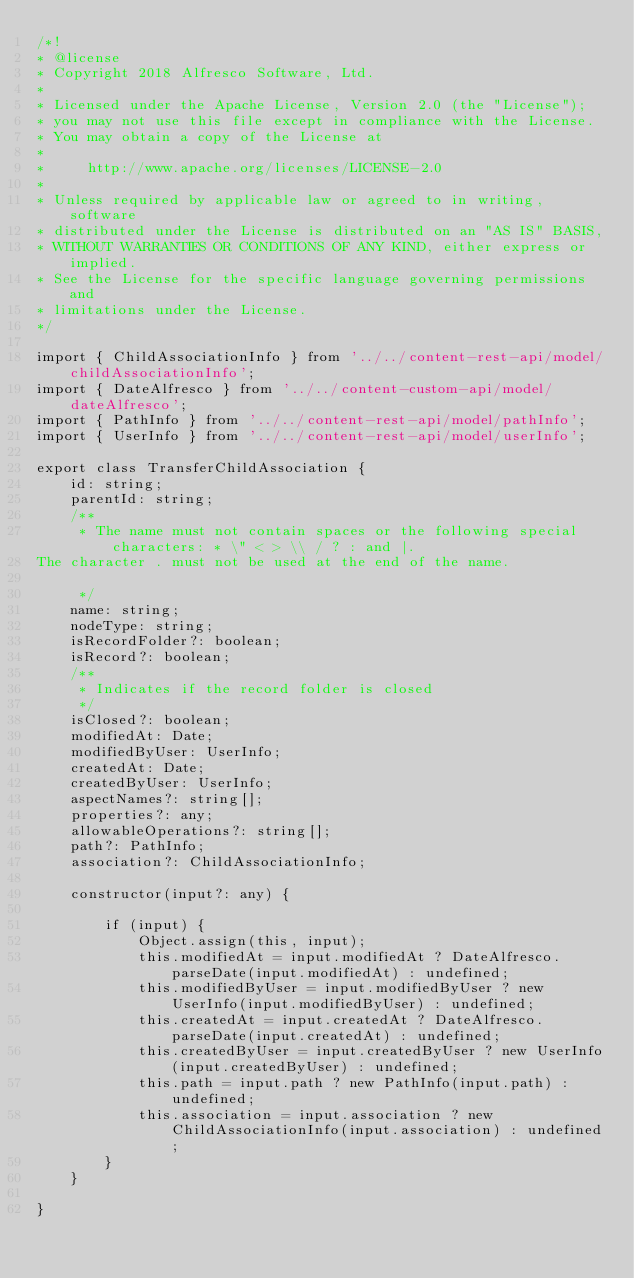<code> <loc_0><loc_0><loc_500><loc_500><_TypeScript_>/*!
* @license
* Copyright 2018 Alfresco Software, Ltd.
*
* Licensed under the Apache License, Version 2.0 (the "License");
* you may not use this file except in compliance with the License.
* You may obtain a copy of the License at
*
*     http://www.apache.org/licenses/LICENSE-2.0
*
* Unless required by applicable law or agreed to in writing, software
* distributed under the License is distributed on an "AS IS" BASIS,
* WITHOUT WARRANTIES OR CONDITIONS OF ANY KIND, either express or implied.
* See the License for the specific language governing permissions and
* limitations under the License.
*/

import { ChildAssociationInfo } from '../../content-rest-api/model/childAssociationInfo';
import { DateAlfresco } from '../../content-custom-api/model/dateAlfresco';
import { PathInfo } from '../../content-rest-api/model/pathInfo';
import { UserInfo } from '../../content-rest-api/model/userInfo';

export class TransferChildAssociation {
    id: string;
    parentId: string;
    /**
     * The name must not contain spaces or the following special characters: * \" < > \\ / ? : and |.
The character . must not be used at the end of the name.

     */
    name: string;
    nodeType: string;
    isRecordFolder?: boolean;
    isRecord?: boolean;
    /**
     * Indicates if the record folder is closed
     */
    isClosed?: boolean;
    modifiedAt: Date;
    modifiedByUser: UserInfo;
    createdAt: Date;
    createdByUser: UserInfo;
    aspectNames?: string[];
    properties?: any;
    allowableOperations?: string[];
    path?: PathInfo;
    association?: ChildAssociationInfo;

    constructor(input?: any) {

        if (input) {
            Object.assign(this, input);
            this.modifiedAt = input.modifiedAt ? DateAlfresco.parseDate(input.modifiedAt) : undefined;
            this.modifiedByUser = input.modifiedByUser ? new UserInfo(input.modifiedByUser) : undefined;
            this.createdAt = input.createdAt ? DateAlfresco.parseDate(input.createdAt) : undefined;
            this.createdByUser = input.createdByUser ? new UserInfo(input.createdByUser) : undefined;
            this.path = input.path ? new PathInfo(input.path) : undefined;
            this.association = input.association ? new ChildAssociationInfo(input.association) : undefined;
        }
    }

}
</code> 